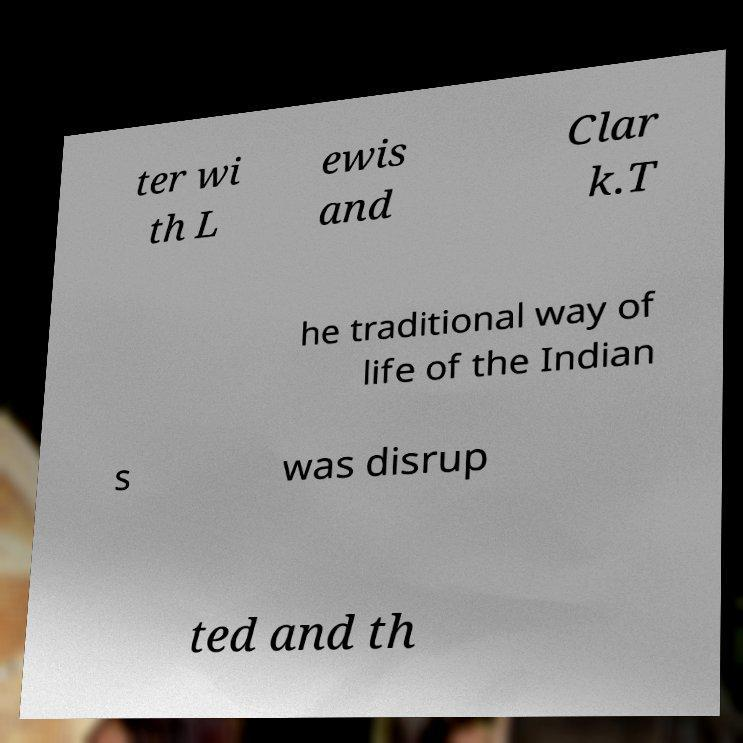Could you assist in decoding the text presented in this image and type it out clearly? ter wi th L ewis and Clar k.T he traditional way of life of the Indian s was disrup ted and th 